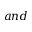<formula> <loc_0><loc_0><loc_500><loc_500>a n d</formula> 